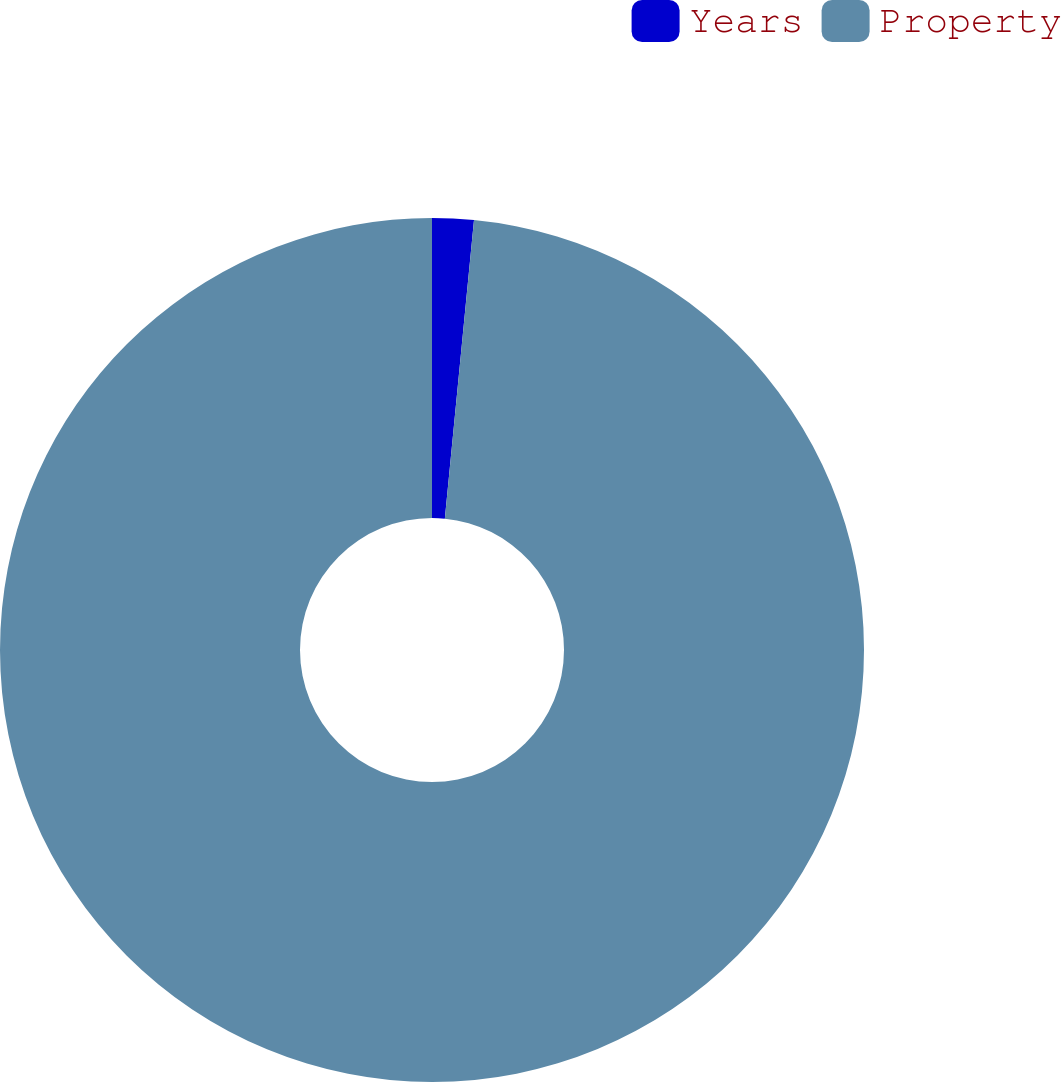<chart> <loc_0><loc_0><loc_500><loc_500><pie_chart><fcel>Years<fcel>Property<nl><fcel>1.55%<fcel>98.45%<nl></chart> 